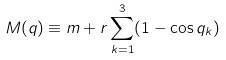Convert formula to latex. <formula><loc_0><loc_0><loc_500><loc_500>M ( { q } ) \equiv m + r \sum _ { k = 1 } ^ { 3 } ( 1 - \cos q _ { k } )</formula> 